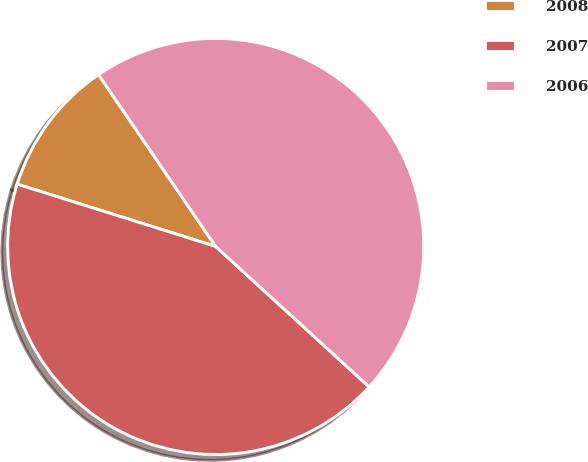Convert chart to OTSL. <chart><loc_0><loc_0><loc_500><loc_500><pie_chart><fcel>2008<fcel>2007<fcel>2006<nl><fcel>10.63%<fcel>43.05%<fcel>46.32%<nl></chart> 